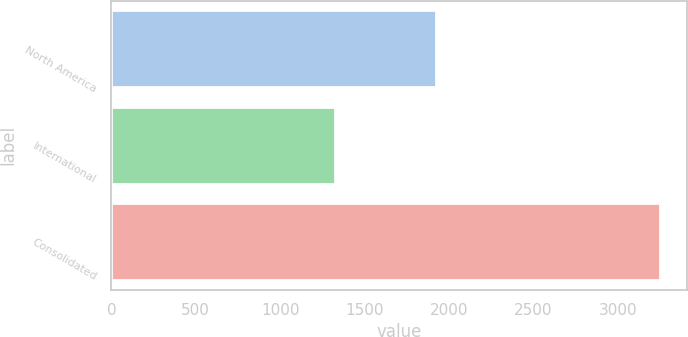<chart> <loc_0><loc_0><loc_500><loc_500><bar_chart><fcel>North America<fcel>International<fcel>Consolidated<nl><fcel>1921<fcel>1327<fcel>3248<nl></chart> 